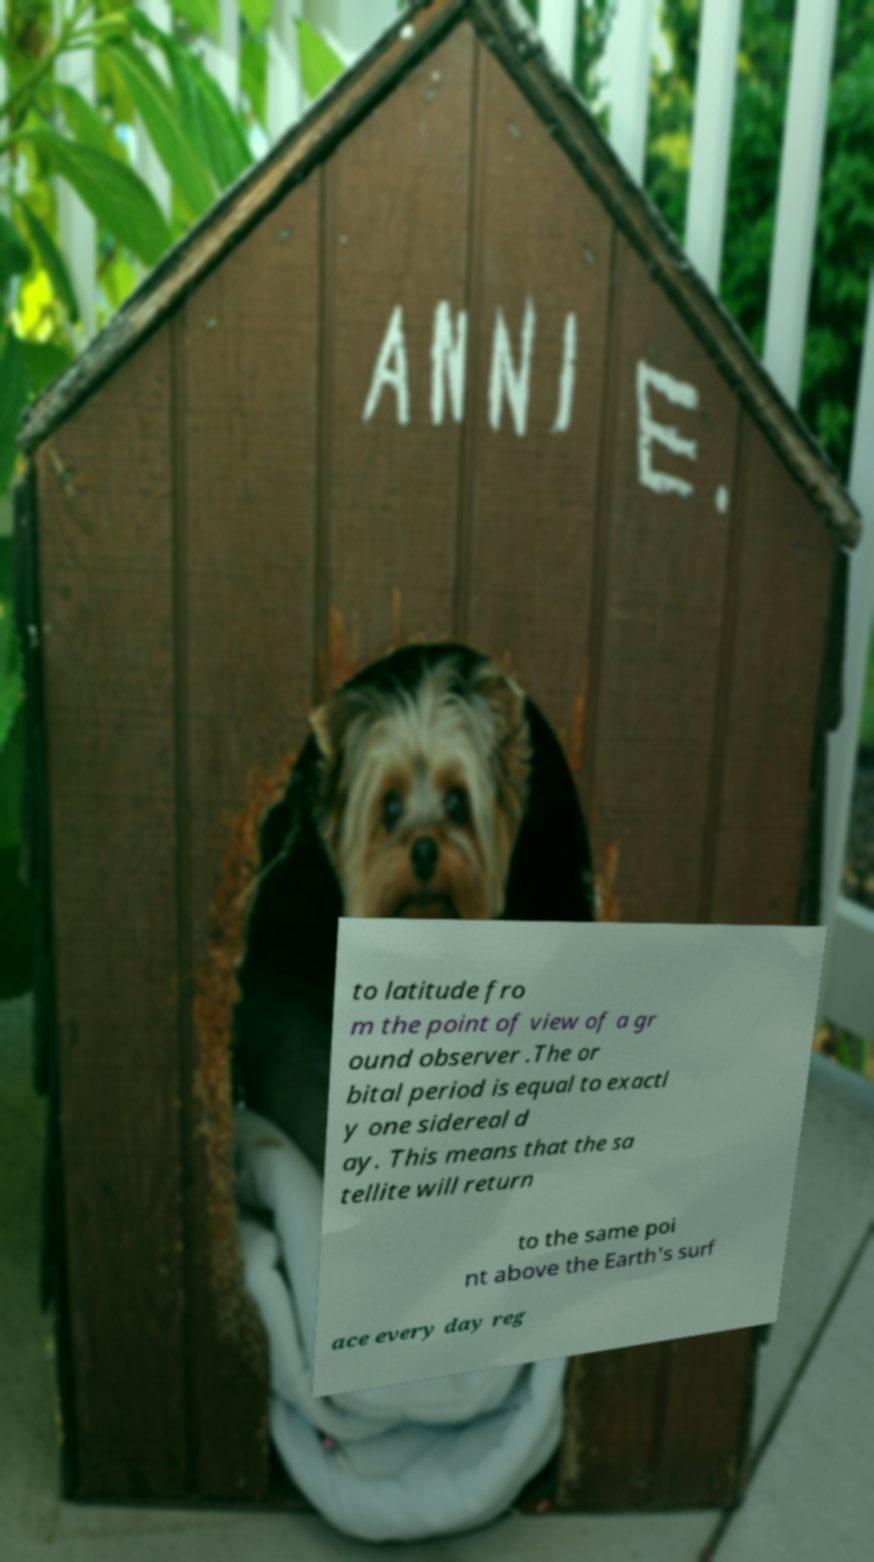Can you read and provide the text displayed in the image?This photo seems to have some interesting text. Can you extract and type it out for me? to latitude fro m the point of view of a gr ound observer .The or bital period is equal to exactl y one sidereal d ay. This means that the sa tellite will return to the same poi nt above the Earth's surf ace every day reg 